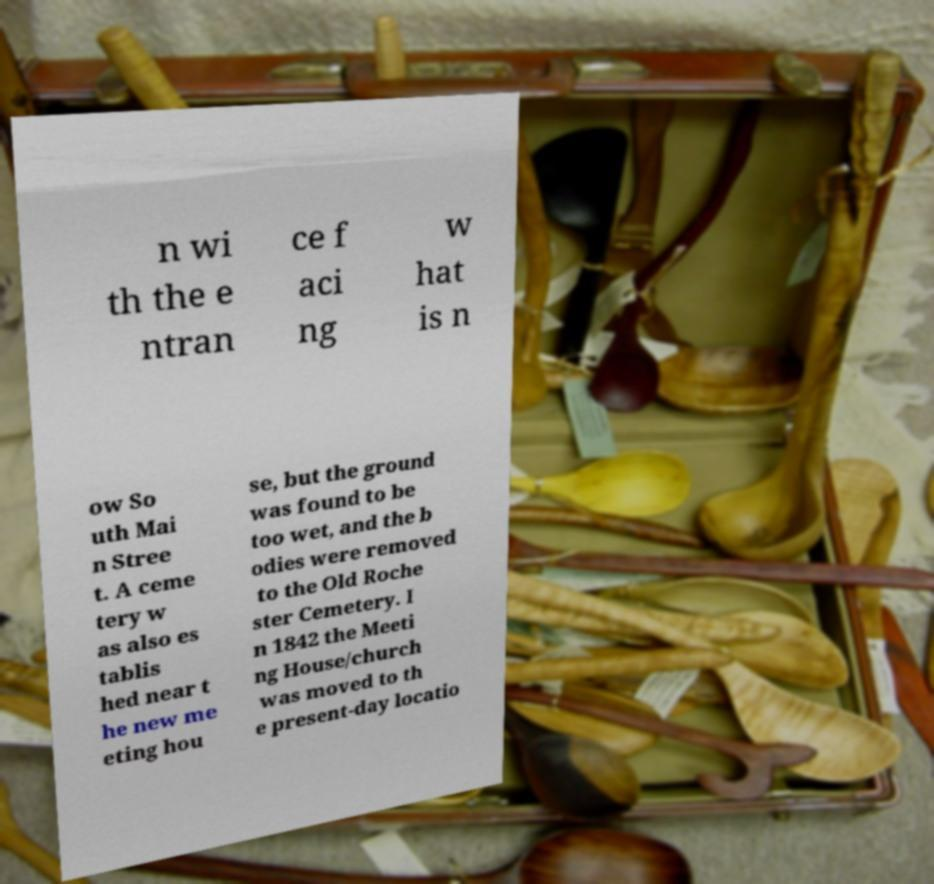Please identify and transcribe the text found in this image. n wi th the e ntran ce f aci ng w hat is n ow So uth Mai n Stree t. A ceme tery w as also es tablis hed near t he new me eting hou se, but the ground was found to be too wet, and the b odies were removed to the Old Roche ster Cemetery. I n 1842 the Meeti ng House/church was moved to th e present-day locatio 